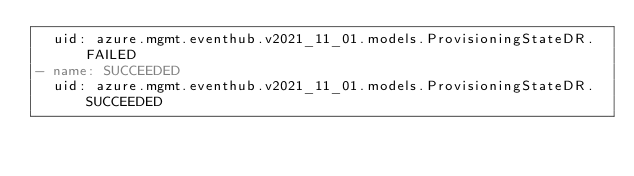Convert code to text. <code><loc_0><loc_0><loc_500><loc_500><_YAML_>  uid: azure.mgmt.eventhub.v2021_11_01.models.ProvisioningStateDR.FAILED
- name: SUCCEEDED
  uid: azure.mgmt.eventhub.v2021_11_01.models.ProvisioningStateDR.SUCCEEDED
</code> 